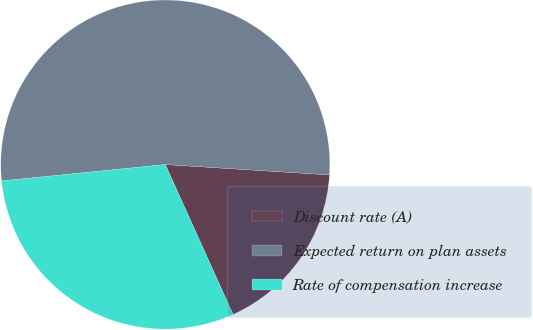Convert chart to OTSL. <chart><loc_0><loc_0><loc_500><loc_500><pie_chart><fcel>Discount rate (A)<fcel>Expected return on plan assets<fcel>Rate of compensation increase<nl><fcel>17.24%<fcel>52.59%<fcel>30.17%<nl></chart> 